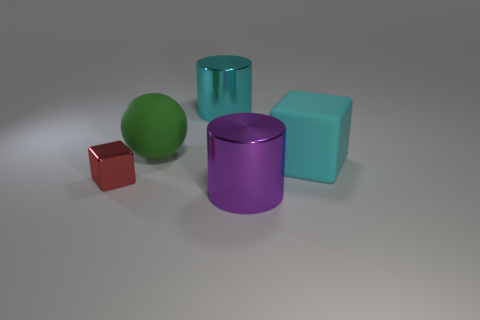Add 5 red shiny spheres. How many objects exist? 10 Subtract all balls. How many objects are left? 4 Add 5 green rubber balls. How many green rubber balls are left? 6 Add 5 tiny red cubes. How many tiny red cubes exist? 6 Subtract 1 red cubes. How many objects are left? 4 Subtract all matte balls. Subtract all large cubes. How many objects are left? 3 